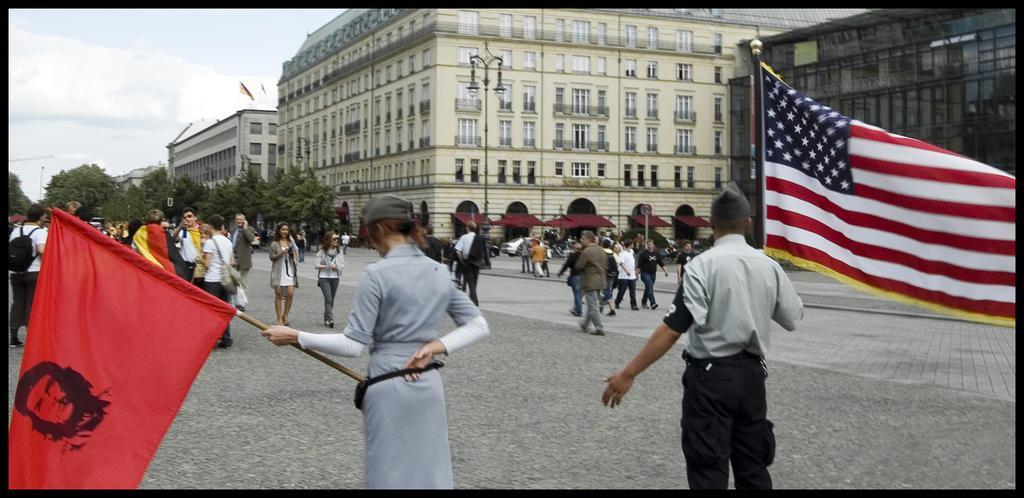Could you give a brief overview of what you see in this image? This is an outside view. At the bottom there are two persons holding flags in their hands and standing on the road facing towards the back side. In the background there are many people walking on the ground and also I can see few trees and buildings. At the top of the image I can see the sky. 